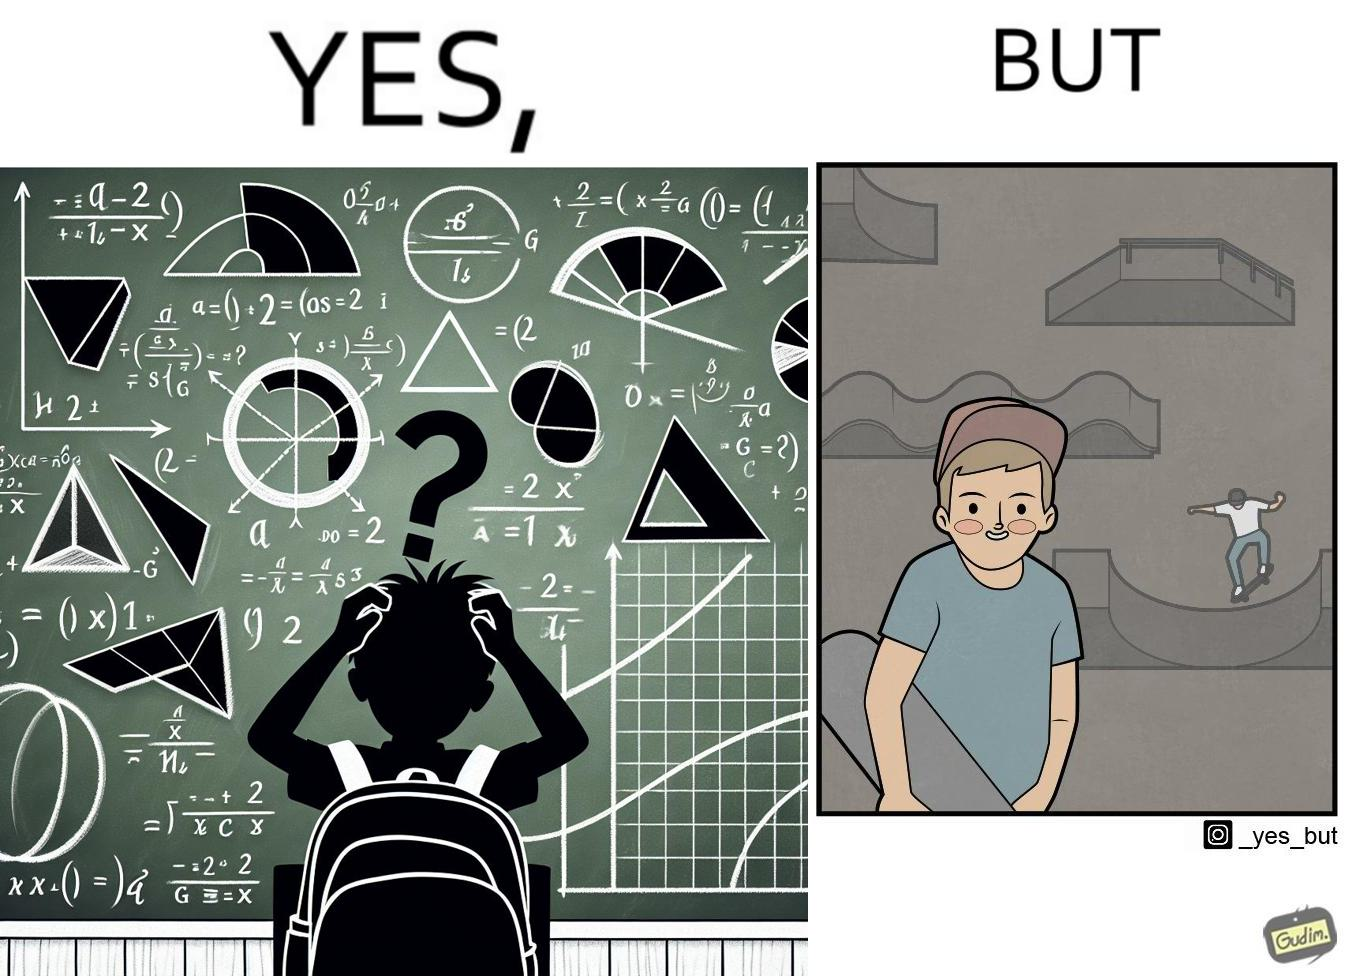Why is this image considered satirical? The image is ironical beaucse while the boy does not enjoy studying mathematics and different geometric shapes like semi circle and trapezoid and graphs of trigonometric equations like that of a sine wave, he enjoys skateboarding on surfaces and bowls that are built based on the said geometric shapes and graphs of trigonometric equations. 